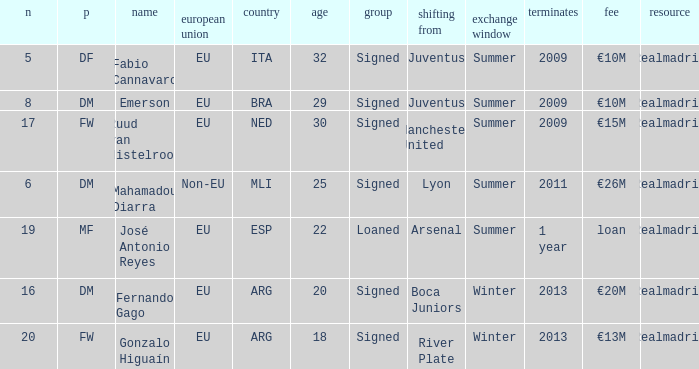What is the type of the player whose transfer fee was €20m? Signed. 